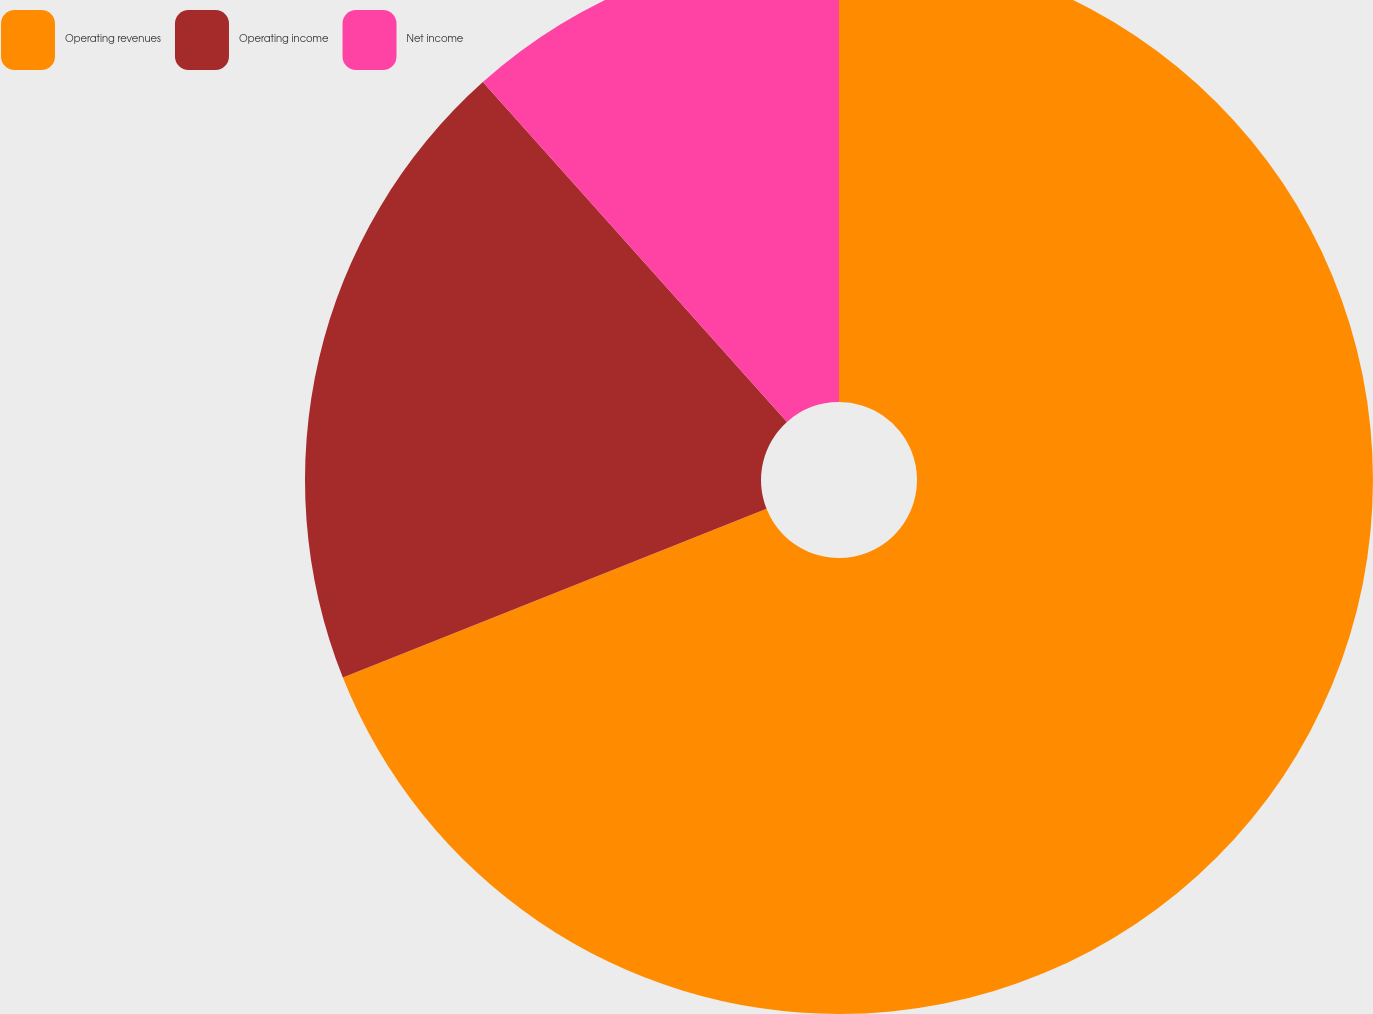Convert chart. <chart><loc_0><loc_0><loc_500><loc_500><pie_chart><fcel>Operating revenues<fcel>Operating income<fcel>Net income<nl><fcel>68.97%<fcel>19.41%<fcel>11.62%<nl></chart> 